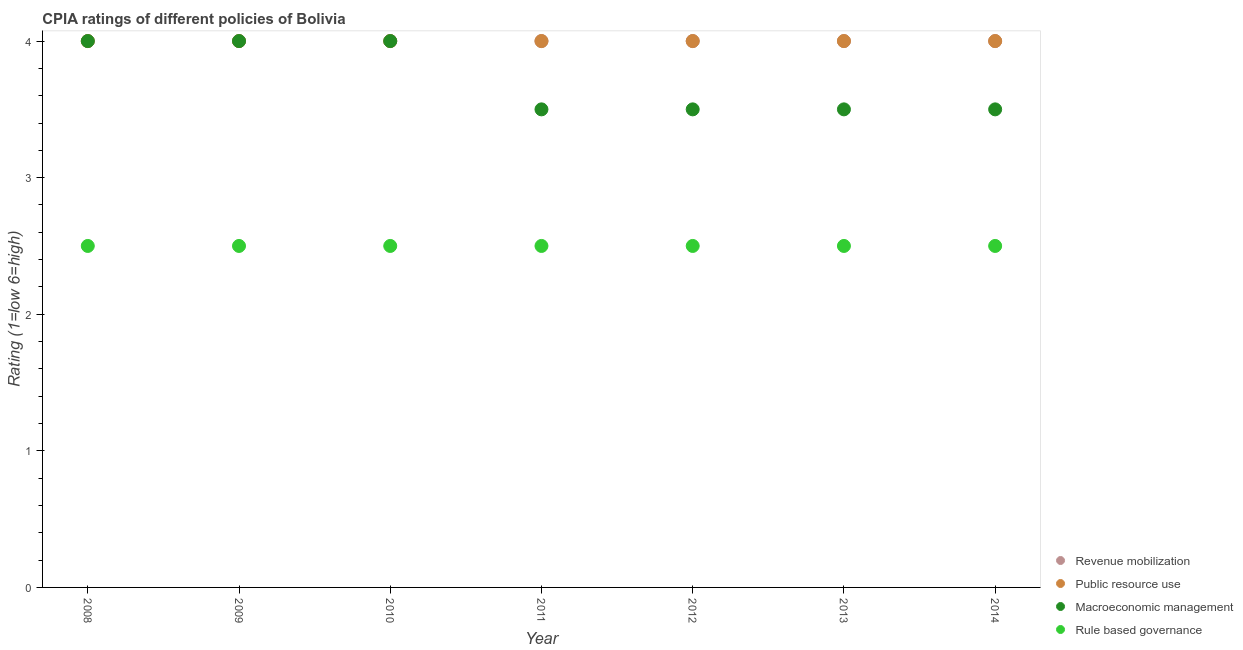How many different coloured dotlines are there?
Provide a short and direct response. 4. Is the number of dotlines equal to the number of legend labels?
Your response must be concise. Yes. What is the cpia rating of revenue mobilization in 2009?
Your answer should be compact. 4. Across all years, what is the maximum cpia rating of public resource use?
Your answer should be compact. 4. Across all years, what is the minimum cpia rating of public resource use?
Keep it short and to the point. 4. In which year was the cpia rating of public resource use maximum?
Your answer should be compact. 2008. In which year was the cpia rating of public resource use minimum?
Make the answer very short. 2008. What is the total cpia rating of public resource use in the graph?
Provide a succinct answer. 28. What is the difference between the cpia rating of revenue mobilization in 2008 and that in 2012?
Your answer should be very brief. 0. What is the difference between the cpia rating of public resource use in 2014 and the cpia rating of rule based governance in 2012?
Give a very brief answer. 1.5. In the year 2011, what is the difference between the cpia rating of macroeconomic management and cpia rating of revenue mobilization?
Your response must be concise. -0.5. What is the ratio of the cpia rating of macroeconomic management in 2008 to that in 2012?
Give a very brief answer. 1.14. Is the difference between the cpia rating of public resource use in 2009 and 2010 greater than the difference between the cpia rating of macroeconomic management in 2009 and 2010?
Ensure brevity in your answer.  No. What is the difference between the highest and the lowest cpia rating of rule based governance?
Offer a very short reply. 0. In how many years, is the cpia rating of public resource use greater than the average cpia rating of public resource use taken over all years?
Your answer should be compact. 0. Is it the case that in every year, the sum of the cpia rating of public resource use and cpia rating of macroeconomic management is greater than the sum of cpia rating of rule based governance and cpia rating of revenue mobilization?
Provide a short and direct response. No. Is it the case that in every year, the sum of the cpia rating of revenue mobilization and cpia rating of public resource use is greater than the cpia rating of macroeconomic management?
Keep it short and to the point. Yes. Are the values on the major ticks of Y-axis written in scientific E-notation?
Give a very brief answer. No. Does the graph contain any zero values?
Offer a terse response. No. Does the graph contain grids?
Keep it short and to the point. No. How are the legend labels stacked?
Offer a very short reply. Vertical. What is the title of the graph?
Your answer should be compact. CPIA ratings of different policies of Bolivia. Does "Primary" appear as one of the legend labels in the graph?
Offer a terse response. No. What is the label or title of the X-axis?
Your answer should be compact. Year. What is the Rating (1=low 6=high) of Revenue mobilization in 2008?
Offer a very short reply. 4. What is the Rating (1=low 6=high) of Macroeconomic management in 2008?
Ensure brevity in your answer.  4. What is the Rating (1=low 6=high) in Rule based governance in 2009?
Ensure brevity in your answer.  2.5. What is the Rating (1=low 6=high) in Public resource use in 2010?
Offer a terse response. 4. What is the Rating (1=low 6=high) in Revenue mobilization in 2011?
Offer a very short reply. 4. What is the Rating (1=low 6=high) in Public resource use in 2011?
Your response must be concise. 4. What is the Rating (1=low 6=high) in Macroeconomic management in 2011?
Keep it short and to the point. 3.5. What is the Rating (1=low 6=high) of Revenue mobilization in 2012?
Your response must be concise. 4. What is the Rating (1=low 6=high) in Public resource use in 2012?
Keep it short and to the point. 4. What is the Rating (1=low 6=high) in Rule based governance in 2012?
Ensure brevity in your answer.  2.5. What is the Rating (1=low 6=high) of Public resource use in 2013?
Give a very brief answer. 4. What is the Rating (1=low 6=high) in Macroeconomic management in 2013?
Provide a short and direct response. 3.5. What is the Rating (1=low 6=high) of Rule based governance in 2013?
Provide a succinct answer. 2.5. Across all years, what is the maximum Rating (1=low 6=high) of Revenue mobilization?
Your answer should be compact. 4. Across all years, what is the minimum Rating (1=low 6=high) of Rule based governance?
Your answer should be very brief. 2.5. What is the total Rating (1=low 6=high) of Macroeconomic management in the graph?
Your response must be concise. 26. What is the total Rating (1=low 6=high) in Rule based governance in the graph?
Ensure brevity in your answer.  17.5. What is the difference between the Rating (1=low 6=high) in Revenue mobilization in 2008 and that in 2009?
Offer a very short reply. 0. What is the difference between the Rating (1=low 6=high) of Public resource use in 2008 and that in 2009?
Provide a short and direct response. 0. What is the difference between the Rating (1=low 6=high) in Macroeconomic management in 2008 and that in 2009?
Keep it short and to the point. 0. What is the difference between the Rating (1=low 6=high) of Rule based governance in 2008 and that in 2009?
Your answer should be compact. 0. What is the difference between the Rating (1=low 6=high) of Revenue mobilization in 2008 and that in 2010?
Give a very brief answer. 0. What is the difference between the Rating (1=low 6=high) in Macroeconomic management in 2008 and that in 2010?
Keep it short and to the point. 0. What is the difference between the Rating (1=low 6=high) in Rule based governance in 2008 and that in 2010?
Keep it short and to the point. 0. What is the difference between the Rating (1=low 6=high) in Revenue mobilization in 2008 and that in 2011?
Keep it short and to the point. 0. What is the difference between the Rating (1=low 6=high) of Macroeconomic management in 2008 and that in 2011?
Make the answer very short. 0.5. What is the difference between the Rating (1=low 6=high) in Rule based governance in 2008 and that in 2011?
Your response must be concise. 0. What is the difference between the Rating (1=low 6=high) in Revenue mobilization in 2008 and that in 2012?
Ensure brevity in your answer.  0. What is the difference between the Rating (1=low 6=high) of Public resource use in 2008 and that in 2012?
Keep it short and to the point. 0. What is the difference between the Rating (1=low 6=high) in Macroeconomic management in 2008 and that in 2012?
Provide a succinct answer. 0.5. What is the difference between the Rating (1=low 6=high) in Rule based governance in 2008 and that in 2012?
Make the answer very short. 0. What is the difference between the Rating (1=low 6=high) in Public resource use in 2008 and that in 2013?
Ensure brevity in your answer.  0. What is the difference between the Rating (1=low 6=high) in Macroeconomic management in 2008 and that in 2013?
Ensure brevity in your answer.  0.5. What is the difference between the Rating (1=low 6=high) of Rule based governance in 2008 and that in 2013?
Offer a very short reply. 0. What is the difference between the Rating (1=low 6=high) in Revenue mobilization in 2008 and that in 2014?
Your answer should be compact. 0. What is the difference between the Rating (1=low 6=high) of Public resource use in 2008 and that in 2014?
Provide a short and direct response. 0. What is the difference between the Rating (1=low 6=high) of Macroeconomic management in 2008 and that in 2014?
Provide a short and direct response. 0.5. What is the difference between the Rating (1=low 6=high) of Rule based governance in 2008 and that in 2014?
Your answer should be very brief. 0. What is the difference between the Rating (1=low 6=high) in Public resource use in 2009 and that in 2010?
Make the answer very short. 0. What is the difference between the Rating (1=low 6=high) in Macroeconomic management in 2009 and that in 2010?
Ensure brevity in your answer.  0. What is the difference between the Rating (1=low 6=high) of Rule based governance in 2009 and that in 2010?
Offer a terse response. 0. What is the difference between the Rating (1=low 6=high) in Public resource use in 2009 and that in 2011?
Offer a terse response. 0. What is the difference between the Rating (1=low 6=high) of Revenue mobilization in 2009 and that in 2012?
Your response must be concise. 0. What is the difference between the Rating (1=low 6=high) of Public resource use in 2009 and that in 2012?
Offer a very short reply. 0. What is the difference between the Rating (1=low 6=high) in Macroeconomic management in 2009 and that in 2012?
Offer a very short reply. 0.5. What is the difference between the Rating (1=low 6=high) in Rule based governance in 2009 and that in 2012?
Keep it short and to the point. 0. What is the difference between the Rating (1=low 6=high) in Public resource use in 2009 and that in 2013?
Make the answer very short. 0. What is the difference between the Rating (1=low 6=high) in Macroeconomic management in 2009 and that in 2013?
Offer a terse response. 0.5. What is the difference between the Rating (1=low 6=high) of Public resource use in 2009 and that in 2014?
Give a very brief answer. 0. What is the difference between the Rating (1=low 6=high) of Rule based governance in 2009 and that in 2014?
Make the answer very short. 0. What is the difference between the Rating (1=low 6=high) of Public resource use in 2010 and that in 2011?
Keep it short and to the point. 0. What is the difference between the Rating (1=low 6=high) in Macroeconomic management in 2010 and that in 2011?
Offer a very short reply. 0.5. What is the difference between the Rating (1=low 6=high) of Revenue mobilization in 2010 and that in 2012?
Offer a terse response. 0. What is the difference between the Rating (1=low 6=high) of Public resource use in 2010 and that in 2012?
Give a very brief answer. 0. What is the difference between the Rating (1=low 6=high) of Macroeconomic management in 2010 and that in 2012?
Make the answer very short. 0.5. What is the difference between the Rating (1=low 6=high) of Public resource use in 2010 and that in 2013?
Provide a short and direct response. 0. What is the difference between the Rating (1=low 6=high) in Rule based governance in 2010 and that in 2013?
Your response must be concise. 0. What is the difference between the Rating (1=low 6=high) in Public resource use in 2010 and that in 2014?
Provide a short and direct response. 0. What is the difference between the Rating (1=low 6=high) in Macroeconomic management in 2010 and that in 2014?
Offer a very short reply. 0.5. What is the difference between the Rating (1=low 6=high) in Rule based governance in 2010 and that in 2014?
Give a very brief answer. 0. What is the difference between the Rating (1=low 6=high) of Macroeconomic management in 2011 and that in 2012?
Your answer should be very brief. 0. What is the difference between the Rating (1=low 6=high) in Rule based governance in 2011 and that in 2012?
Provide a short and direct response. 0. What is the difference between the Rating (1=low 6=high) in Public resource use in 2011 and that in 2013?
Give a very brief answer. 0. What is the difference between the Rating (1=low 6=high) in Macroeconomic management in 2011 and that in 2013?
Keep it short and to the point. 0. What is the difference between the Rating (1=low 6=high) in Revenue mobilization in 2011 and that in 2014?
Give a very brief answer. 0. What is the difference between the Rating (1=low 6=high) in Macroeconomic management in 2011 and that in 2014?
Offer a terse response. 0. What is the difference between the Rating (1=low 6=high) of Public resource use in 2012 and that in 2013?
Keep it short and to the point. 0. What is the difference between the Rating (1=low 6=high) of Macroeconomic management in 2012 and that in 2013?
Provide a succinct answer. 0. What is the difference between the Rating (1=low 6=high) of Rule based governance in 2012 and that in 2013?
Offer a very short reply. 0. What is the difference between the Rating (1=low 6=high) of Rule based governance in 2012 and that in 2014?
Keep it short and to the point. 0. What is the difference between the Rating (1=low 6=high) of Public resource use in 2013 and that in 2014?
Give a very brief answer. 0. What is the difference between the Rating (1=low 6=high) of Macroeconomic management in 2013 and that in 2014?
Offer a terse response. 0. What is the difference between the Rating (1=low 6=high) in Revenue mobilization in 2008 and the Rating (1=low 6=high) in Macroeconomic management in 2009?
Ensure brevity in your answer.  0. What is the difference between the Rating (1=low 6=high) of Public resource use in 2008 and the Rating (1=low 6=high) of Macroeconomic management in 2009?
Your response must be concise. 0. What is the difference between the Rating (1=low 6=high) of Public resource use in 2008 and the Rating (1=low 6=high) of Rule based governance in 2009?
Give a very brief answer. 1.5. What is the difference between the Rating (1=low 6=high) in Macroeconomic management in 2008 and the Rating (1=low 6=high) in Rule based governance in 2009?
Offer a terse response. 1.5. What is the difference between the Rating (1=low 6=high) in Public resource use in 2008 and the Rating (1=low 6=high) in Macroeconomic management in 2010?
Offer a terse response. 0. What is the difference between the Rating (1=low 6=high) of Revenue mobilization in 2008 and the Rating (1=low 6=high) of Public resource use in 2011?
Offer a terse response. 0. What is the difference between the Rating (1=low 6=high) of Revenue mobilization in 2008 and the Rating (1=low 6=high) of Macroeconomic management in 2011?
Keep it short and to the point. 0.5. What is the difference between the Rating (1=low 6=high) of Public resource use in 2008 and the Rating (1=low 6=high) of Rule based governance in 2011?
Offer a very short reply. 1.5. What is the difference between the Rating (1=low 6=high) of Macroeconomic management in 2008 and the Rating (1=low 6=high) of Rule based governance in 2011?
Make the answer very short. 1.5. What is the difference between the Rating (1=low 6=high) in Revenue mobilization in 2008 and the Rating (1=low 6=high) in Macroeconomic management in 2013?
Your answer should be compact. 0.5. What is the difference between the Rating (1=low 6=high) in Public resource use in 2008 and the Rating (1=low 6=high) in Macroeconomic management in 2013?
Your answer should be very brief. 0.5. What is the difference between the Rating (1=low 6=high) of Macroeconomic management in 2008 and the Rating (1=low 6=high) of Rule based governance in 2013?
Provide a short and direct response. 1.5. What is the difference between the Rating (1=low 6=high) in Revenue mobilization in 2008 and the Rating (1=low 6=high) in Public resource use in 2014?
Your answer should be compact. 0. What is the difference between the Rating (1=low 6=high) of Public resource use in 2008 and the Rating (1=low 6=high) of Macroeconomic management in 2014?
Give a very brief answer. 0.5. What is the difference between the Rating (1=low 6=high) of Public resource use in 2008 and the Rating (1=low 6=high) of Rule based governance in 2014?
Offer a terse response. 1.5. What is the difference between the Rating (1=low 6=high) of Macroeconomic management in 2008 and the Rating (1=low 6=high) of Rule based governance in 2014?
Your answer should be compact. 1.5. What is the difference between the Rating (1=low 6=high) of Revenue mobilization in 2009 and the Rating (1=low 6=high) of Macroeconomic management in 2010?
Give a very brief answer. 0. What is the difference between the Rating (1=low 6=high) of Macroeconomic management in 2009 and the Rating (1=low 6=high) of Rule based governance in 2010?
Provide a succinct answer. 1.5. What is the difference between the Rating (1=low 6=high) in Revenue mobilization in 2009 and the Rating (1=low 6=high) in Public resource use in 2011?
Your answer should be compact. 0. What is the difference between the Rating (1=low 6=high) in Public resource use in 2009 and the Rating (1=low 6=high) in Macroeconomic management in 2011?
Ensure brevity in your answer.  0.5. What is the difference between the Rating (1=low 6=high) in Macroeconomic management in 2009 and the Rating (1=low 6=high) in Rule based governance in 2011?
Provide a short and direct response. 1.5. What is the difference between the Rating (1=low 6=high) of Revenue mobilization in 2009 and the Rating (1=low 6=high) of Public resource use in 2012?
Your answer should be very brief. 0. What is the difference between the Rating (1=low 6=high) in Revenue mobilization in 2009 and the Rating (1=low 6=high) in Rule based governance in 2012?
Your answer should be very brief. 1.5. What is the difference between the Rating (1=low 6=high) of Revenue mobilization in 2009 and the Rating (1=low 6=high) of Macroeconomic management in 2013?
Offer a very short reply. 0.5. What is the difference between the Rating (1=low 6=high) of Revenue mobilization in 2009 and the Rating (1=low 6=high) of Rule based governance in 2013?
Your response must be concise. 1.5. What is the difference between the Rating (1=low 6=high) of Public resource use in 2009 and the Rating (1=low 6=high) of Macroeconomic management in 2013?
Your answer should be very brief. 0.5. What is the difference between the Rating (1=low 6=high) of Public resource use in 2009 and the Rating (1=low 6=high) of Rule based governance in 2013?
Your response must be concise. 1.5. What is the difference between the Rating (1=low 6=high) of Revenue mobilization in 2009 and the Rating (1=low 6=high) of Public resource use in 2014?
Offer a very short reply. 0. What is the difference between the Rating (1=low 6=high) of Revenue mobilization in 2009 and the Rating (1=low 6=high) of Rule based governance in 2014?
Your response must be concise. 1.5. What is the difference between the Rating (1=low 6=high) in Public resource use in 2009 and the Rating (1=low 6=high) in Macroeconomic management in 2014?
Ensure brevity in your answer.  0.5. What is the difference between the Rating (1=low 6=high) in Public resource use in 2009 and the Rating (1=low 6=high) in Rule based governance in 2014?
Keep it short and to the point. 1.5. What is the difference between the Rating (1=low 6=high) of Revenue mobilization in 2010 and the Rating (1=low 6=high) of Macroeconomic management in 2011?
Give a very brief answer. 0.5. What is the difference between the Rating (1=low 6=high) in Revenue mobilization in 2010 and the Rating (1=low 6=high) in Rule based governance in 2011?
Provide a short and direct response. 1.5. What is the difference between the Rating (1=low 6=high) in Macroeconomic management in 2010 and the Rating (1=low 6=high) in Rule based governance in 2011?
Your response must be concise. 1.5. What is the difference between the Rating (1=low 6=high) of Revenue mobilization in 2010 and the Rating (1=low 6=high) of Public resource use in 2012?
Ensure brevity in your answer.  0. What is the difference between the Rating (1=low 6=high) of Macroeconomic management in 2010 and the Rating (1=low 6=high) of Rule based governance in 2012?
Offer a terse response. 1.5. What is the difference between the Rating (1=low 6=high) in Revenue mobilization in 2010 and the Rating (1=low 6=high) in Public resource use in 2013?
Make the answer very short. 0. What is the difference between the Rating (1=low 6=high) of Revenue mobilization in 2010 and the Rating (1=low 6=high) of Macroeconomic management in 2013?
Give a very brief answer. 0.5. What is the difference between the Rating (1=low 6=high) in Revenue mobilization in 2010 and the Rating (1=low 6=high) in Rule based governance in 2013?
Provide a succinct answer. 1.5. What is the difference between the Rating (1=low 6=high) in Public resource use in 2010 and the Rating (1=low 6=high) in Macroeconomic management in 2013?
Your answer should be compact. 0.5. What is the difference between the Rating (1=low 6=high) of Public resource use in 2010 and the Rating (1=low 6=high) of Rule based governance in 2013?
Your answer should be compact. 1.5. What is the difference between the Rating (1=low 6=high) in Public resource use in 2010 and the Rating (1=low 6=high) in Macroeconomic management in 2014?
Ensure brevity in your answer.  0.5. What is the difference between the Rating (1=low 6=high) in Public resource use in 2010 and the Rating (1=low 6=high) in Rule based governance in 2014?
Provide a succinct answer. 1.5. What is the difference between the Rating (1=low 6=high) of Macroeconomic management in 2010 and the Rating (1=low 6=high) of Rule based governance in 2014?
Your answer should be compact. 1.5. What is the difference between the Rating (1=low 6=high) in Revenue mobilization in 2011 and the Rating (1=low 6=high) in Macroeconomic management in 2012?
Your answer should be compact. 0.5. What is the difference between the Rating (1=low 6=high) in Revenue mobilization in 2011 and the Rating (1=low 6=high) in Rule based governance in 2012?
Give a very brief answer. 1.5. What is the difference between the Rating (1=low 6=high) in Revenue mobilization in 2011 and the Rating (1=low 6=high) in Public resource use in 2013?
Ensure brevity in your answer.  0. What is the difference between the Rating (1=low 6=high) of Revenue mobilization in 2011 and the Rating (1=low 6=high) of Macroeconomic management in 2013?
Keep it short and to the point. 0.5. What is the difference between the Rating (1=low 6=high) in Revenue mobilization in 2011 and the Rating (1=low 6=high) in Rule based governance in 2013?
Give a very brief answer. 1.5. What is the difference between the Rating (1=low 6=high) of Public resource use in 2011 and the Rating (1=low 6=high) of Rule based governance in 2013?
Offer a very short reply. 1.5. What is the difference between the Rating (1=low 6=high) in Macroeconomic management in 2011 and the Rating (1=low 6=high) in Rule based governance in 2014?
Your answer should be compact. 1. What is the difference between the Rating (1=low 6=high) in Revenue mobilization in 2012 and the Rating (1=low 6=high) in Macroeconomic management in 2013?
Your answer should be very brief. 0.5. What is the difference between the Rating (1=low 6=high) of Revenue mobilization in 2012 and the Rating (1=low 6=high) of Rule based governance in 2013?
Your answer should be very brief. 1.5. What is the difference between the Rating (1=low 6=high) in Public resource use in 2012 and the Rating (1=low 6=high) in Rule based governance in 2013?
Your answer should be compact. 1.5. What is the difference between the Rating (1=low 6=high) in Public resource use in 2012 and the Rating (1=low 6=high) in Rule based governance in 2014?
Make the answer very short. 1.5. What is the difference between the Rating (1=low 6=high) in Revenue mobilization in 2013 and the Rating (1=low 6=high) in Macroeconomic management in 2014?
Your answer should be very brief. 0.5. What is the average Rating (1=low 6=high) of Public resource use per year?
Make the answer very short. 4. What is the average Rating (1=low 6=high) in Macroeconomic management per year?
Keep it short and to the point. 3.71. What is the average Rating (1=low 6=high) of Rule based governance per year?
Ensure brevity in your answer.  2.5. In the year 2008, what is the difference between the Rating (1=low 6=high) in Revenue mobilization and Rating (1=low 6=high) in Macroeconomic management?
Provide a short and direct response. 0. In the year 2008, what is the difference between the Rating (1=low 6=high) in Revenue mobilization and Rating (1=low 6=high) in Rule based governance?
Ensure brevity in your answer.  1.5. In the year 2008, what is the difference between the Rating (1=low 6=high) in Public resource use and Rating (1=low 6=high) in Rule based governance?
Offer a very short reply. 1.5. In the year 2008, what is the difference between the Rating (1=low 6=high) of Macroeconomic management and Rating (1=low 6=high) of Rule based governance?
Provide a short and direct response. 1.5. In the year 2009, what is the difference between the Rating (1=low 6=high) of Revenue mobilization and Rating (1=low 6=high) of Public resource use?
Ensure brevity in your answer.  0. In the year 2009, what is the difference between the Rating (1=low 6=high) in Revenue mobilization and Rating (1=low 6=high) in Macroeconomic management?
Your answer should be compact. 0. In the year 2009, what is the difference between the Rating (1=low 6=high) in Public resource use and Rating (1=low 6=high) in Rule based governance?
Keep it short and to the point. 1.5. In the year 2009, what is the difference between the Rating (1=low 6=high) in Macroeconomic management and Rating (1=low 6=high) in Rule based governance?
Your answer should be very brief. 1.5. In the year 2010, what is the difference between the Rating (1=low 6=high) of Revenue mobilization and Rating (1=low 6=high) of Public resource use?
Provide a succinct answer. 0. In the year 2010, what is the difference between the Rating (1=low 6=high) of Revenue mobilization and Rating (1=low 6=high) of Macroeconomic management?
Keep it short and to the point. 0. In the year 2010, what is the difference between the Rating (1=low 6=high) in Revenue mobilization and Rating (1=low 6=high) in Rule based governance?
Ensure brevity in your answer.  1.5. In the year 2011, what is the difference between the Rating (1=low 6=high) in Revenue mobilization and Rating (1=low 6=high) in Public resource use?
Provide a succinct answer. 0. In the year 2011, what is the difference between the Rating (1=low 6=high) of Revenue mobilization and Rating (1=low 6=high) of Macroeconomic management?
Make the answer very short. 0.5. In the year 2011, what is the difference between the Rating (1=low 6=high) of Revenue mobilization and Rating (1=low 6=high) of Rule based governance?
Your answer should be very brief. 1.5. In the year 2011, what is the difference between the Rating (1=low 6=high) in Public resource use and Rating (1=low 6=high) in Macroeconomic management?
Your answer should be very brief. 0.5. In the year 2011, what is the difference between the Rating (1=low 6=high) in Public resource use and Rating (1=low 6=high) in Rule based governance?
Provide a succinct answer. 1.5. In the year 2011, what is the difference between the Rating (1=low 6=high) of Macroeconomic management and Rating (1=low 6=high) of Rule based governance?
Ensure brevity in your answer.  1. In the year 2012, what is the difference between the Rating (1=low 6=high) of Revenue mobilization and Rating (1=low 6=high) of Public resource use?
Offer a terse response. 0. In the year 2012, what is the difference between the Rating (1=low 6=high) of Revenue mobilization and Rating (1=low 6=high) of Macroeconomic management?
Make the answer very short. 0.5. In the year 2012, what is the difference between the Rating (1=low 6=high) of Revenue mobilization and Rating (1=low 6=high) of Rule based governance?
Provide a succinct answer. 1.5. In the year 2012, what is the difference between the Rating (1=low 6=high) in Public resource use and Rating (1=low 6=high) in Macroeconomic management?
Make the answer very short. 0.5. In the year 2013, what is the difference between the Rating (1=low 6=high) in Revenue mobilization and Rating (1=low 6=high) in Public resource use?
Make the answer very short. 0. In the year 2013, what is the difference between the Rating (1=low 6=high) of Revenue mobilization and Rating (1=low 6=high) of Rule based governance?
Give a very brief answer. 1.5. In the year 2013, what is the difference between the Rating (1=low 6=high) of Macroeconomic management and Rating (1=low 6=high) of Rule based governance?
Your answer should be very brief. 1. In the year 2014, what is the difference between the Rating (1=low 6=high) of Revenue mobilization and Rating (1=low 6=high) of Public resource use?
Provide a succinct answer. 0. In the year 2014, what is the difference between the Rating (1=low 6=high) of Revenue mobilization and Rating (1=low 6=high) of Macroeconomic management?
Make the answer very short. 0.5. In the year 2014, what is the difference between the Rating (1=low 6=high) of Revenue mobilization and Rating (1=low 6=high) of Rule based governance?
Offer a terse response. 1.5. What is the ratio of the Rating (1=low 6=high) in Revenue mobilization in 2008 to that in 2009?
Offer a terse response. 1. What is the ratio of the Rating (1=low 6=high) of Macroeconomic management in 2008 to that in 2009?
Make the answer very short. 1. What is the ratio of the Rating (1=low 6=high) of Rule based governance in 2008 to that in 2009?
Offer a very short reply. 1. What is the ratio of the Rating (1=low 6=high) in Revenue mobilization in 2008 to that in 2010?
Give a very brief answer. 1. What is the ratio of the Rating (1=low 6=high) in Public resource use in 2008 to that in 2010?
Offer a very short reply. 1. What is the ratio of the Rating (1=low 6=high) in Macroeconomic management in 2008 to that in 2010?
Give a very brief answer. 1. What is the ratio of the Rating (1=low 6=high) of Public resource use in 2008 to that in 2011?
Ensure brevity in your answer.  1. What is the ratio of the Rating (1=low 6=high) of Macroeconomic management in 2008 to that in 2011?
Offer a terse response. 1.14. What is the ratio of the Rating (1=low 6=high) in Rule based governance in 2008 to that in 2011?
Your answer should be compact. 1. What is the ratio of the Rating (1=low 6=high) of Macroeconomic management in 2008 to that in 2012?
Make the answer very short. 1.14. What is the ratio of the Rating (1=low 6=high) of Public resource use in 2008 to that in 2013?
Keep it short and to the point. 1. What is the ratio of the Rating (1=low 6=high) of Macroeconomic management in 2008 to that in 2013?
Provide a succinct answer. 1.14. What is the ratio of the Rating (1=low 6=high) of Revenue mobilization in 2008 to that in 2014?
Offer a very short reply. 1. What is the ratio of the Rating (1=low 6=high) in Public resource use in 2008 to that in 2014?
Offer a terse response. 1. What is the ratio of the Rating (1=low 6=high) in Macroeconomic management in 2008 to that in 2014?
Offer a terse response. 1.14. What is the ratio of the Rating (1=low 6=high) of Rule based governance in 2008 to that in 2014?
Provide a succinct answer. 1. What is the ratio of the Rating (1=low 6=high) of Macroeconomic management in 2009 to that in 2011?
Provide a short and direct response. 1.14. What is the ratio of the Rating (1=low 6=high) in Revenue mobilization in 2009 to that in 2012?
Make the answer very short. 1. What is the ratio of the Rating (1=low 6=high) in Rule based governance in 2009 to that in 2012?
Provide a short and direct response. 1. What is the ratio of the Rating (1=low 6=high) in Revenue mobilization in 2009 to that in 2013?
Provide a short and direct response. 1. What is the ratio of the Rating (1=low 6=high) of Macroeconomic management in 2009 to that in 2013?
Your answer should be compact. 1.14. What is the ratio of the Rating (1=low 6=high) in Macroeconomic management in 2009 to that in 2014?
Your answer should be very brief. 1.14. What is the ratio of the Rating (1=low 6=high) in Rule based governance in 2009 to that in 2014?
Give a very brief answer. 1. What is the ratio of the Rating (1=low 6=high) in Macroeconomic management in 2010 to that in 2011?
Provide a short and direct response. 1.14. What is the ratio of the Rating (1=low 6=high) in Rule based governance in 2010 to that in 2011?
Offer a very short reply. 1. What is the ratio of the Rating (1=low 6=high) in Revenue mobilization in 2010 to that in 2012?
Give a very brief answer. 1. What is the ratio of the Rating (1=low 6=high) in Rule based governance in 2010 to that in 2012?
Provide a short and direct response. 1. What is the ratio of the Rating (1=low 6=high) in Public resource use in 2010 to that in 2013?
Your answer should be compact. 1. What is the ratio of the Rating (1=low 6=high) in Revenue mobilization in 2010 to that in 2014?
Ensure brevity in your answer.  1. What is the ratio of the Rating (1=low 6=high) in Public resource use in 2010 to that in 2014?
Offer a terse response. 1. What is the ratio of the Rating (1=low 6=high) in Rule based governance in 2010 to that in 2014?
Offer a very short reply. 1. What is the ratio of the Rating (1=low 6=high) of Macroeconomic management in 2011 to that in 2012?
Make the answer very short. 1. What is the ratio of the Rating (1=low 6=high) of Rule based governance in 2011 to that in 2012?
Offer a very short reply. 1. What is the ratio of the Rating (1=low 6=high) of Public resource use in 2011 to that in 2013?
Your answer should be compact. 1. What is the ratio of the Rating (1=low 6=high) of Macroeconomic management in 2011 to that in 2013?
Keep it short and to the point. 1. What is the ratio of the Rating (1=low 6=high) of Rule based governance in 2011 to that in 2013?
Give a very brief answer. 1. What is the ratio of the Rating (1=low 6=high) of Macroeconomic management in 2011 to that in 2014?
Make the answer very short. 1. What is the ratio of the Rating (1=low 6=high) of Revenue mobilization in 2012 to that in 2013?
Provide a short and direct response. 1. What is the ratio of the Rating (1=low 6=high) of Public resource use in 2012 to that in 2014?
Keep it short and to the point. 1. What is the ratio of the Rating (1=low 6=high) of Revenue mobilization in 2013 to that in 2014?
Offer a terse response. 1. What is the difference between the highest and the second highest Rating (1=low 6=high) in Public resource use?
Make the answer very short. 0. What is the difference between the highest and the second highest Rating (1=low 6=high) in Rule based governance?
Provide a succinct answer. 0. What is the difference between the highest and the lowest Rating (1=low 6=high) of Revenue mobilization?
Provide a short and direct response. 0. What is the difference between the highest and the lowest Rating (1=low 6=high) of Public resource use?
Your answer should be compact. 0. 